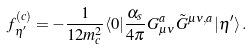Convert formula to latex. <formula><loc_0><loc_0><loc_500><loc_500>f _ { \eta ^ { \prime } } ^ { ( c ) } = - \frac { 1 } { 1 2 m _ { c } ^ { 2 } } \langle 0 | \frac { \alpha _ { s } } { 4 \pi } G _ { \mu \nu } ^ { a } \tilde { G } ^ { \mu \nu , a } | \eta ^ { \prime } \rangle \, .</formula> 